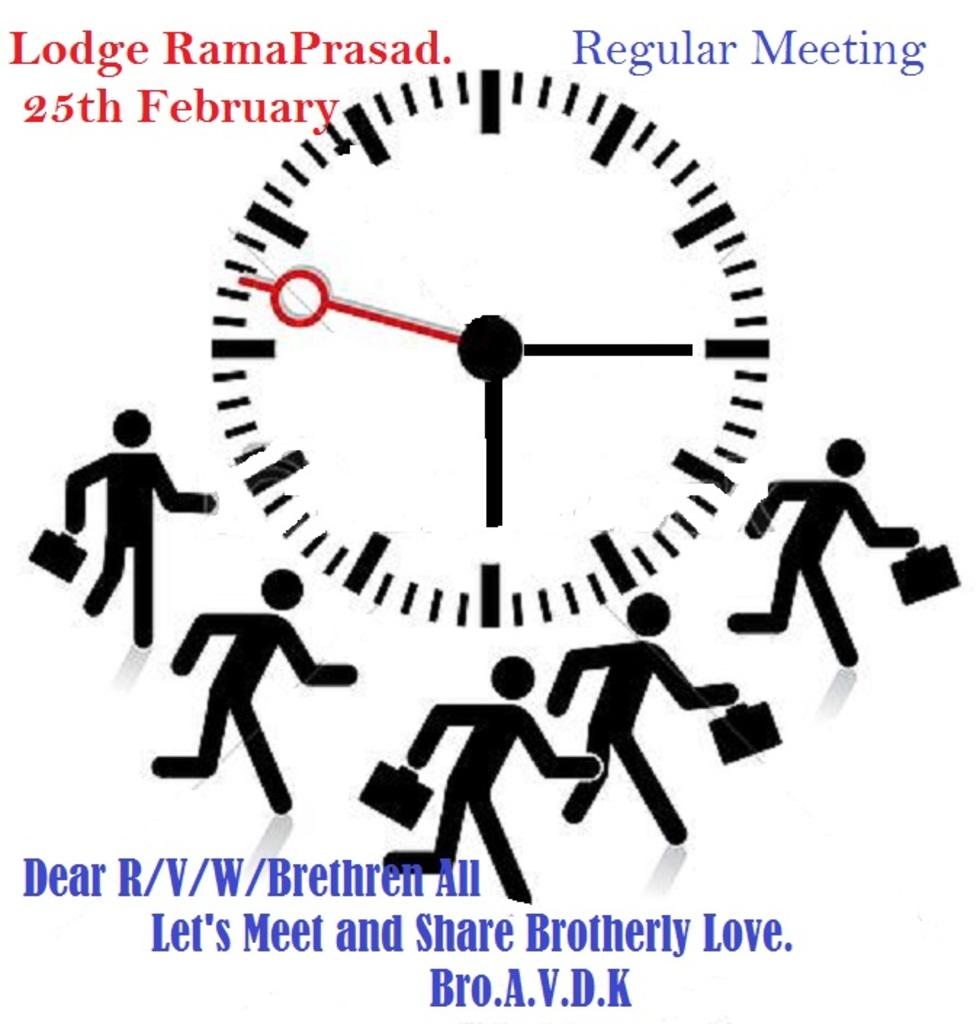What month is this event taking place?
Provide a short and direct response. February. What is the first word in blue?
Offer a terse response. Regular. 